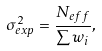<formula> <loc_0><loc_0><loc_500><loc_500>\sigma _ { e x p } ^ { 2 } = \frac { N _ { e f f } } { \sum w _ { i } } ,</formula> 